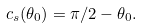<formula> <loc_0><loc_0><loc_500><loc_500>c _ { s } ( \theta _ { 0 } ) = \pi / 2 - \theta _ { 0 } .</formula> 